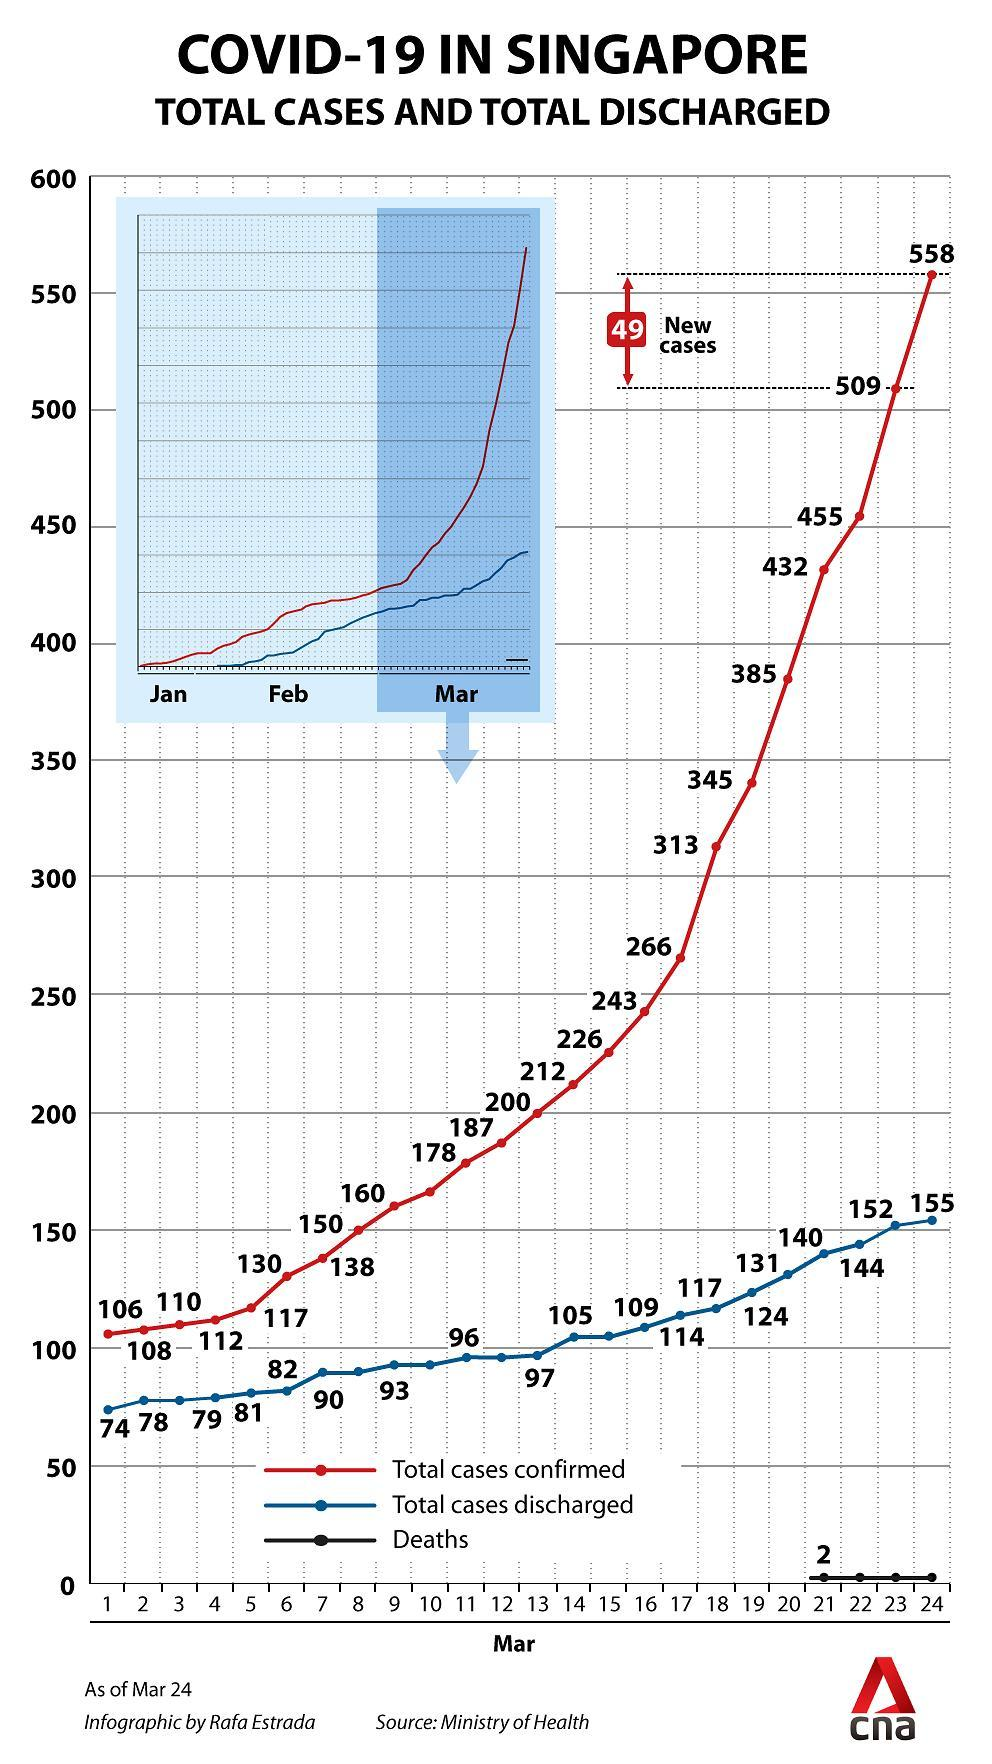What is the total number of Covid patients discharged in Singapore as on March 16?
Answer the question with a short phrase. 109 What is the total number of COVID-19 deaths reported in Singapore as on March 21? 2 What is the total number of confirmed COVID-19 cases reported in Singapore as on March 23? 509 When was the highest number of COVID-19 cases reported in Singapore as per the given data? Mar 24 What is the total number of Covid patients discharged in Singapore as on March 13? 97 What is the total number of Covid patients discharged in Singapore as on March 21? 140 How many new confirmed COVID-19 cases were reported in Singapore on March 24? 49 What is the total number of confirmed COVID-19 cases reported in Singapore as on March 6? 130 